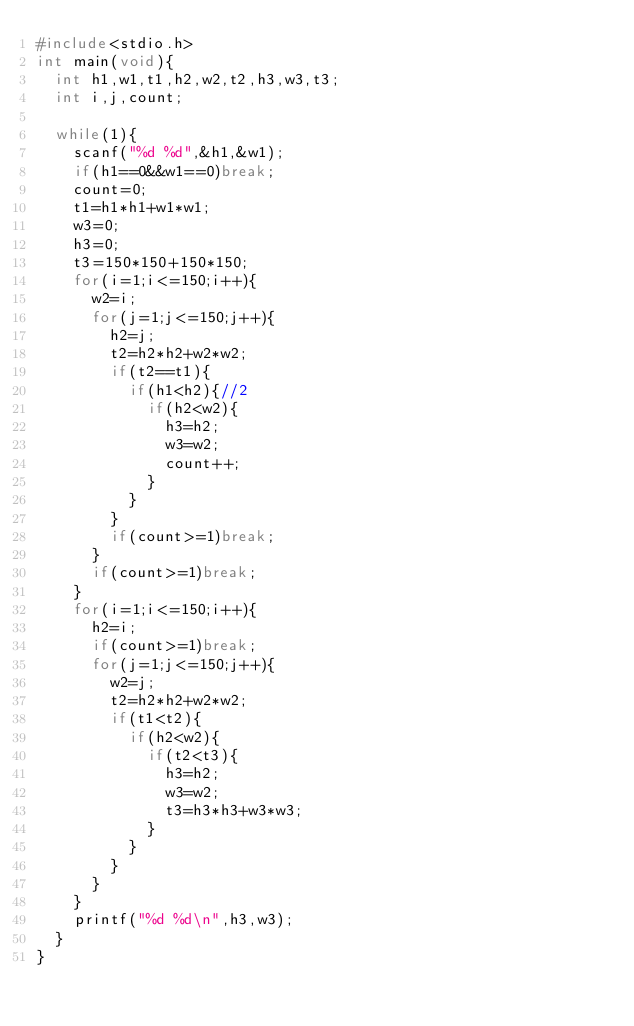Convert code to text. <code><loc_0><loc_0><loc_500><loc_500><_C_>#include<stdio.h>
int main(void){
	int h1,w1,t1,h2,w2,t2,h3,w3,t3;
	int i,j,count;

	while(1){
		scanf("%d %d",&h1,&w1);
		if(h1==0&&w1==0)break;
		count=0;
		t1=h1*h1+w1*w1;
		w3=0;
		h3=0;
		t3=150*150+150*150;
		for(i=1;i<=150;i++){
			w2=i;
			for(j=1;j<=150;j++){
				h2=j;
				t2=h2*h2+w2*w2;
				if(t2==t1){
					if(h1<h2){//2
						if(h2<w2){
							h3=h2;
							w3=w2;
							count++;
						}
					}
				}
				if(count>=1)break;
			}
			if(count>=1)break;
		}
		for(i=1;i<=150;i++){
			h2=i;
			if(count>=1)break;
			for(j=1;j<=150;j++){
				w2=j;
				t2=h2*h2+w2*w2;
				if(t1<t2){
					if(h2<w2){
						if(t2<t3){
							h3=h2;
							w3=w2;
							t3=h3*h3+w3*w3;
						}
					}
				}
			}
		}
		printf("%d %d\n",h3,w3);
	}
}</code> 